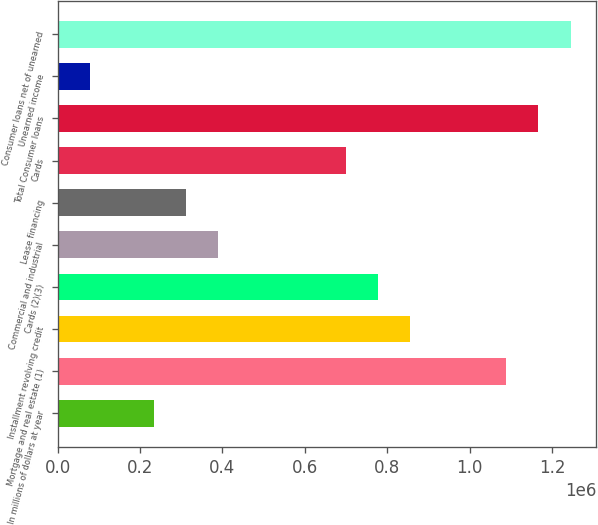Convert chart to OTSL. <chart><loc_0><loc_0><loc_500><loc_500><bar_chart><fcel>In millions of dollars at year<fcel>Mortgage and real estate (1)<fcel>Installment revolving credit<fcel>Cards (2)(3)<fcel>Commercial and industrial<fcel>Lease financing<fcel>Cards<fcel>Total Consumer loans<fcel>Unearned income<fcel>Consumer loans net of unearned<nl><fcel>233399<fcel>1.08919e+06<fcel>855792<fcel>777993<fcel>388998<fcel>311198<fcel>700194<fcel>1.16699e+06<fcel>77801.2<fcel>1.24479e+06<nl></chart> 